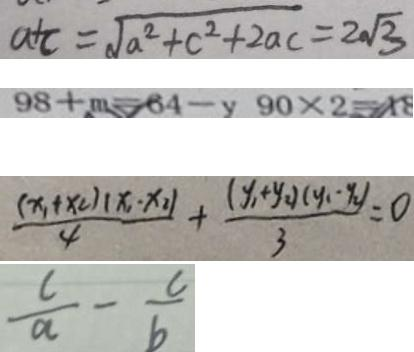Convert formula to latex. <formula><loc_0><loc_0><loc_500><loc_500>a + c = \sqrt { a ^ { 2 } + c ^ { 2 } + 2 a c } = 2 \sqrt { 3 } 
 9 8 + m = 6 4 - y 9 0 \times 2 = 1 8 
 \frac { ( x _ { 1 } + x _ { 2 } ) ( x _ { 1 } - x _ { 2 } ) } { 4 } + \frac { ( y _ { 1 } + y 2 ) ( y _ { 1 } - y _ { 2 } ) } { 3 } = 0 
 \frac { c } { a } - \frac { c } { b }</formula> 